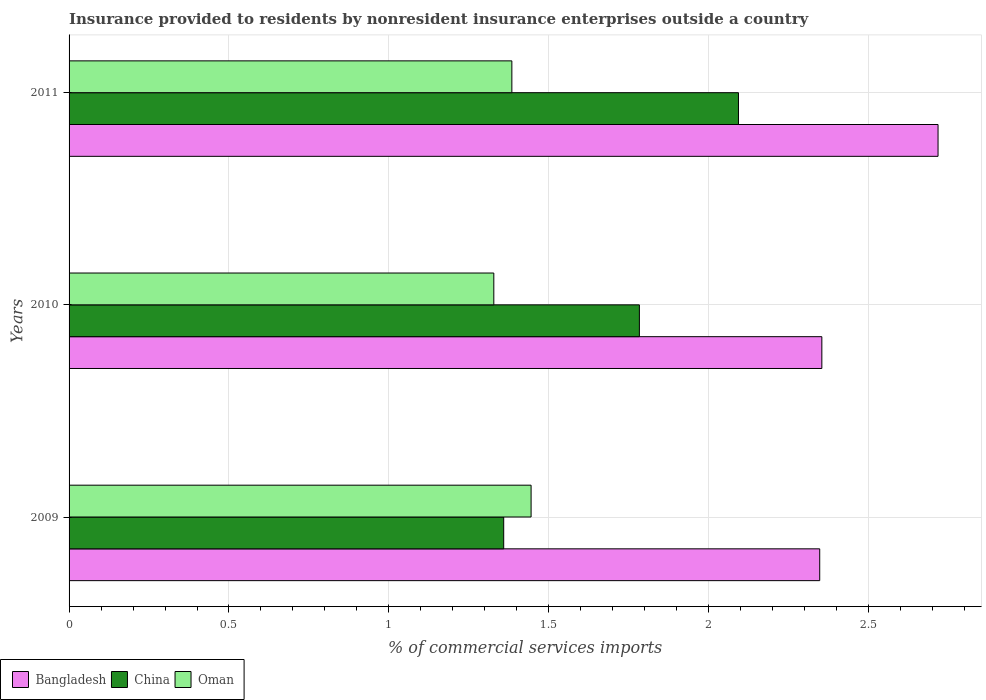How many different coloured bars are there?
Ensure brevity in your answer.  3. How many groups of bars are there?
Your answer should be compact. 3. Are the number of bars on each tick of the Y-axis equal?
Provide a succinct answer. Yes. How many bars are there on the 3rd tick from the top?
Ensure brevity in your answer.  3. What is the Insurance provided to residents in China in 2010?
Your answer should be compact. 1.78. Across all years, what is the maximum Insurance provided to residents in Bangladesh?
Your answer should be very brief. 2.72. Across all years, what is the minimum Insurance provided to residents in China?
Your answer should be very brief. 1.36. In which year was the Insurance provided to residents in Oman maximum?
Provide a short and direct response. 2009. What is the total Insurance provided to residents in Oman in the graph?
Give a very brief answer. 4.16. What is the difference between the Insurance provided to residents in Oman in 2009 and that in 2010?
Your answer should be compact. 0.12. What is the difference between the Insurance provided to residents in Bangladesh in 2010 and the Insurance provided to residents in China in 2009?
Give a very brief answer. 0.99. What is the average Insurance provided to residents in China per year?
Ensure brevity in your answer.  1.75. In the year 2010, what is the difference between the Insurance provided to residents in China and Insurance provided to residents in Oman?
Provide a short and direct response. 0.46. In how many years, is the Insurance provided to residents in China greater than 1.2 %?
Give a very brief answer. 3. What is the ratio of the Insurance provided to residents in Oman in 2010 to that in 2011?
Your response must be concise. 0.96. Is the Insurance provided to residents in China in 2009 less than that in 2011?
Ensure brevity in your answer.  Yes. Is the difference between the Insurance provided to residents in China in 2009 and 2010 greater than the difference between the Insurance provided to residents in Oman in 2009 and 2010?
Keep it short and to the point. No. What is the difference between the highest and the second highest Insurance provided to residents in Bangladesh?
Provide a succinct answer. 0.36. What is the difference between the highest and the lowest Insurance provided to residents in Bangladesh?
Your answer should be compact. 0.37. In how many years, is the Insurance provided to residents in Oman greater than the average Insurance provided to residents in Oman taken over all years?
Keep it short and to the point. 1. Is the sum of the Insurance provided to residents in Oman in 2009 and 2010 greater than the maximum Insurance provided to residents in Bangladesh across all years?
Provide a short and direct response. Yes. Is it the case that in every year, the sum of the Insurance provided to residents in China and Insurance provided to residents in Oman is greater than the Insurance provided to residents in Bangladesh?
Provide a succinct answer. Yes. What is the difference between two consecutive major ticks on the X-axis?
Offer a very short reply. 0.5. Are the values on the major ticks of X-axis written in scientific E-notation?
Provide a short and direct response. No. Does the graph contain grids?
Your answer should be very brief. Yes. How are the legend labels stacked?
Your answer should be very brief. Horizontal. What is the title of the graph?
Provide a succinct answer. Insurance provided to residents by nonresident insurance enterprises outside a country. Does "Samoa" appear as one of the legend labels in the graph?
Your answer should be very brief. No. What is the label or title of the X-axis?
Keep it short and to the point. % of commercial services imports. What is the % of commercial services imports of Bangladesh in 2009?
Offer a very short reply. 2.35. What is the % of commercial services imports in China in 2009?
Your answer should be very brief. 1.36. What is the % of commercial services imports of Oman in 2009?
Your response must be concise. 1.44. What is the % of commercial services imports in Bangladesh in 2010?
Make the answer very short. 2.35. What is the % of commercial services imports in China in 2010?
Provide a succinct answer. 1.78. What is the % of commercial services imports of Oman in 2010?
Offer a very short reply. 1.33. What is the % of commercial services imports in Bangladesh in 2011?
Provide a short and direct response. 2.72. What is the % of commercial services imports of China in 2011?
Offer a very short reply. 2.09. What is the % of commercial services imports of Oman in 2011?
Your answer should be very brief. 1.38. Across all years, what is the maximum % of commercial services imports of Bangladesh?
Ensure brevity in your answer.  2.72. Across all years, what is the maximum % of commercial services imports in China?
Your answer should be compact. 2.09. Across all years, what is the maximum % of commercial services imports of Oman?
Ensure brevity in your answer.  1.44. Across all years, what is the minimum % of commercial services imports of Bangladesh?
Keep it short and to the point. 2.35. Across all years, what is the minimum % of commercial services imports of China?
Ensure brevity in your answer.  1.36. Across all years, what is the minimum % of commercial services imports of Oman?
Keep it short and to the point. 1.33. What is the total % of commercial services imports of Bangladesh in the graph?
Provide a short and direct response. 7.42. What is the total % of commercial services imports of China in the graph?
Provide a succinct answer. 5.24. What is the total % of commercial services imports in Oman in the graph?
Offer a terse response. 4.16. What is the difference between the % of commercial services imports in Bangladesh in 2009 and that in 2010?
Offer a terse response. -0.01. What is the difference between the % of commercial services imports of China in 2009 and that in 2010?
Provide a short and direct response. -0.42. What is the difference between the % of commercial services imports in Oman in 2009 and that in 2010?
Make the answer very short. 0.12. What is the difference between the % of commercial services imports in Bangladesh in 2009 and that in 2011?
Offer a very short reply. -0.37. What is the difference between the % of commercial services imports of China in 2009 and that in 2011?
Ensure brevity in your answer.  -0.73. What is the difference between the % of commercial services imports of Oman in 2009 and that in 2011?
Give a very brief answer. 0.06. What is the difference between the % of commercial services imports of Bangladesh in 2010 and that in 2011?
Provide a succinct answer. -0.36. What is the difference between the % of commercial services imports in China in 2010 and that in 2011?
Offer a terse response. -0.31. What is the difference between the % of commercial services imports in Oman in 2010 and that in 2011?
Keep it short and to the point. -0.06. What is the difference between the % of commercial services imports in Bangladesh in 2009 and the % of commercial services imports in China in 2010?
Offer a terse response. 0.56. What is the difference between the % of commercial services imports of China in 2009 and the % of commercial services imports of Oman in 2010?
Provide a short and direct response. 0.03. What is the difference between the % of commercial services imports in Bangladesh in 2009 and the % of commercial services imports in China in 2011?
Keep it short and to the point. 0.25. What is the difference between the % of commercial services imports of Bangladesh in 2009 and the % of commercial services imports of Oman in 2011?
Make the answer very short. 0.96. What is the difference between the % of commercial services imports in China in 2009 and the % of commercial services imports in Oman in 2011?
Offer a very short reply. -0.03. What is the difference between the % of commercial services imports of Bangladesh in 2010 and the % of commercial services imports of China in 2011?
Offer a very short reply. 0.26. What is the difference between the % of commercial services imports in Bangladesh in 2010 and the % of commercial services imports in Oman in 2011?
Keep it short and to the point. 0.97. What is the difference between the % of commercial services imports in China in 2010 and the % of commercial services imports in Oman in 2011?
Offer a very short reply. 0.4. What is the average % of commercial services imports in Bangladesh per year?
Provide a short and direct response. 2.47. What is the average % of commercial services imports in China per year?
Your answer should be compact. 1.75. What is the average % of commercial services imports in Oman per year?
Offer a very short reply. 1.39. In the year 2009, what is the difference between the % of commercial services imports of Bangladesh and % of commercial services imports of China?
Your answer should be compact. 0.99. In the year 2009, what is the difference between the % of commercial services imports of Bangladesh and % of commercial services imports of Oman?
Provide a short and direct response. 0.9. In the year 2009, what is the difference between the % of commercial services imports in China and % of commercial services imports in Oman?
Offer a terse response. -0.09. In the year 2010, what is the difference between the % of commercial services imports in Bangladesh and % of commercial services imports in China?
Your response must be concise. 0.57. In the year 2010, what is the difference between the % of commercial services imports in Bangladesh and % of commercial services imports in Oman?
Give a very brief answer. 1.03. In the year 2010, what is the difference between the % of commercial services imports in China and % of commercial services imports in Oman?
Make the answer very short. 0.46. In the year 2011, what is the difference between the % of commercial services imports in Bangladesh and % of commercial services imports in China?
Your answer should be compact. 0.62. In the year 2011, what is the difference between the % of commercial services imports in Bangladesh and % of commercial services imports in Oman?
Ensure brevity in your answer.  1.33. In the year 2011, what is the difference between the % of commercial services imports of China and % of commercial services imports of Oman?
Make the answer very short. 0.71. What is the ratio of the % of commercial services imports of Bangladesh in 2009 to that in 2010?
Your answer should be very brief. 1. What is the ratio of the % of commercial services imports in China in 2009 to that in 2010?
Give a very brief answer. 0.76. What is the ratio of the % of commercial services imports in Oman in 2009 to that in 2010?
Your answer should be compact. 1.09. What is the ratio of the % of commercial services imports of Bangladesh in 2009 to that in 2011?
Ensure brevity in your answer.  0.86. What is the ratio of the % of commercial services imports in China in 2009 to that in 2011?
Offer a very short reply. 0.65. What is the ratio of the % of commercial services imports of Oman in 2009 to that in 2011?
Offer a terse response. 1.04. What is the ratio of the % of commercial services imports of Bangladesh in 2010 to that in 2011?
Provide a short and direct response. 0.87. What is the ratio of the % of commercial services imports of China in 2010 to that in 2011?
Offer a terse response. 0.85. What is the ratio of the % of commercial services imports in Oman in 2010 to that in 2011?
Make the answer very short. 0.96. What is the difference between the highest and the second highest % of commercial services imports of Bangladesh?
Your response must be concise. 0.36. What is the difference between the highest and the second highest % of commercial services imports in China?
Your response must be concise. 0.31. What is the difference between the highest and the second highest % of commercial services imports in Oman?
Keep it short and to the point. 0.06. What is the difference between the highest and the lowest % of commercial services imports of Bangladesh?
Offer a terse response. 0.37. What is the difference between the highest and the lowest % of commercial services imports in China?
Offer a very short reply. 0.73. What is the difference between the highest and the lowest % of commercial services imports of Oman?
Provide a short and direct response. 0.12. 